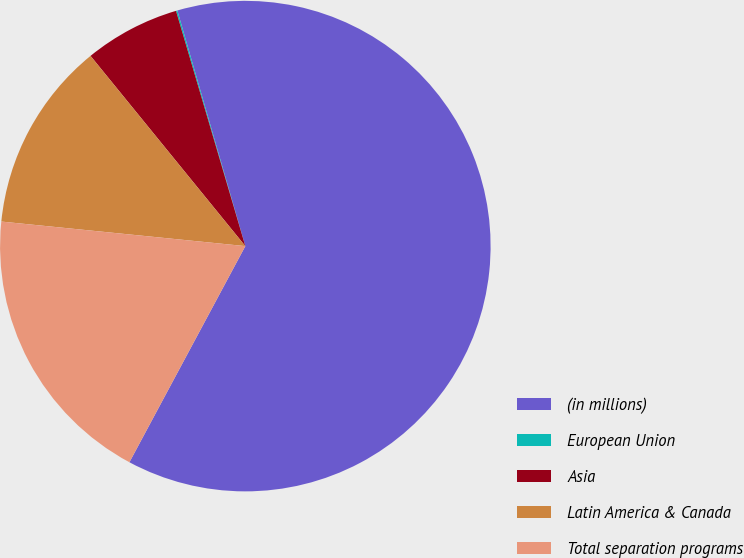<chart> <loc_0><loc_0><loc_500><loc_500><pie_chart><fcel>(in millions)<fcel>European Union<fcel>Asia<fcel>Latin America & Canada<fcel>Total separation programs<nl><fcel>62.3%<fcel>0.09%<fcel>6.31%<fcel>12.53%<fcel>18.76%<nl></chart> 